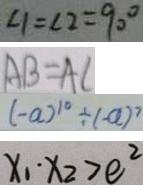<formula> <loc_0><loc_0><loc_500><loc_500>\angle 1 = \angle 2 = 9 0 ^ { \circ } 
 A B = A C 
 ( - a ) ^ { 1 0 } \div ( - a ) ^ { 7 } 
 x _ { 1 } \cdot x _ { 2 } > e ^ { 2 }</formula> 